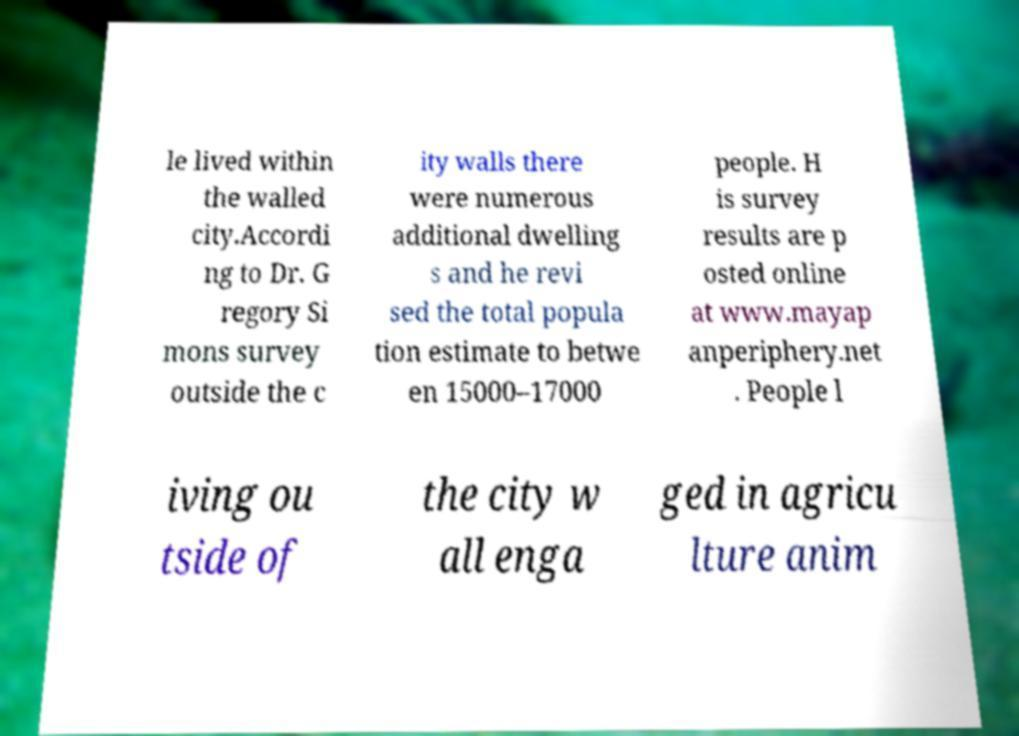Could you extract and type out the text from this image? le lived within the walled city.Accordi ng to Dr. G regory Si mons survey outside the c ity walls there were numerous additional dwelling s and he revi sed the total popula tion estimate to betwe en 15000–17000 people. H is survey results are p osted online at www.mayap anperiphery.net . People l iving ou tside of the city w all enga ged in agricu lture anim 